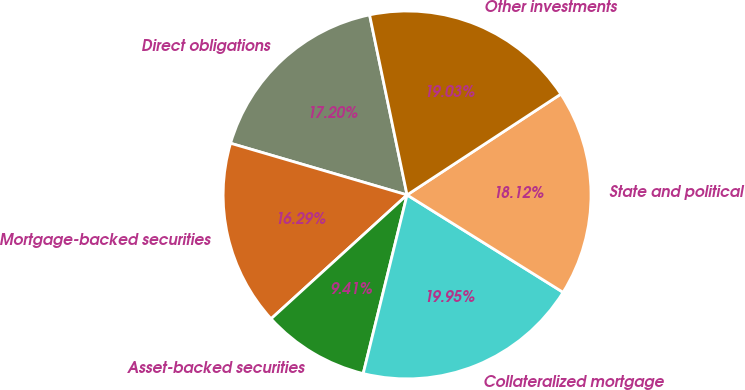Convert chart. <chart><loc_0><loc_0><loc_500><loc_500><pie_chart><fcel>Direct obligations<fcel>Mortgage-backed securities<fcel>Asset-backed securities<fcel>Collateralized mortgage<fcel>State and political<fcel>Other investments<nl><fcel>17.2%<fcel>16.29%<fcel>9.41%<fcel>19.95%<fcel>18.12%<fcel>19.03%<nl></chart> 